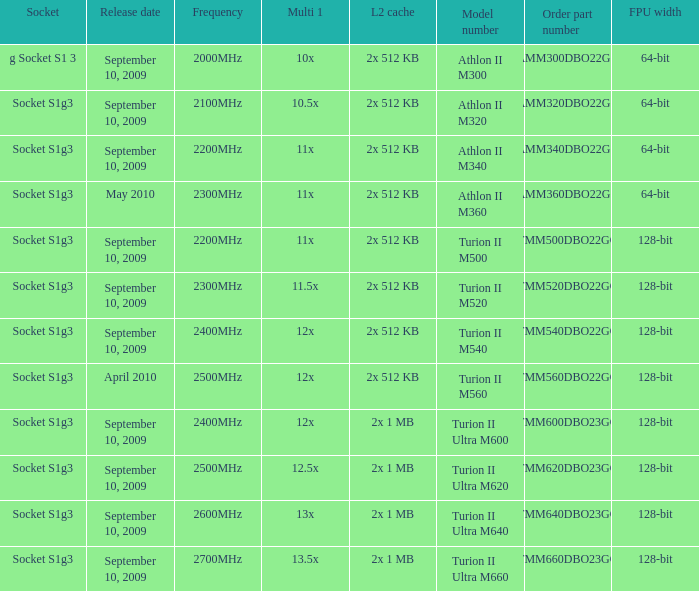Could you parse the entire table? {'header': ['Socket', 'Release date', 'Frequency', 'Multi 1', 'L2 cache', 'Model number', 'Order part number', 'FPU width'], 'rows': [['g Socket S1 3', 'September 10, 2009', '2000MHz', '10x', '2x 512 KB', 'Athlon II M300', 'AMM300DBO22GQ', '64-bit'], ['Socket S1g3', 'September 10, 2009', '2100MHz', '10.5x', '2x 512 KB', 'Athlon II M320', 'AMM320DBO22GQ', '64-bit'], ['Socket S1g3', 'September 10, 2009', '2200MHz', '11x', '2x 512 KB', 'Athlon II M340', 'AMM340DBO22GQ', '64-bit'], ['Socket S1g3', 'May 2010', '2300MHz', '11x', '2x 512 KB', 'Athlon II M360', 'AMM360DBO22GQ', '64-bit'], ['Socket S1g3', 'September 10, 2009', '2200MHz', '11x', '2x 512 KB', 'Turion II M500', 'TMM500DBO22GQ', '128-bit'], ['Socket S1g3', 'September 10, 2009', '2300MHz', '11.5x', '2x 512 KB', 'Turion II M520', 'TMM520DBO22GQ', '128-bit'], ['Socket S1g3', 'September 10, 2009', '2400MHz', '12x', '2x 512 KB', 'Turion II M540', 'TMM540DBO22GQ', '128-bit'], ['Socket S1g3', 'April 2010', '2500MHz', '12x', '2x 512 KB', 'Turion II M560', 'TMM560DBO22GQ', '128-bit'], ['Socket S1g3', 'September 10, 2009', '2400MHz', '12x', '2x 1 MB', 'Turion II Ultra M600', 'TMM600DBO23GQ', '128-bit'], ['Socket S1g3', 'September 10, 2009', '2500MHz', '12.5x', '2x 1 MB', 'Turion II Ultra M620', 'TMM620DBO23GQ', '128-bit'], ['Socket S1g3', 'September 10, 2009', '2600MHz', '13x', '2x 1 MB', 'Turion II Ultra M640', 'TMM640DBO23GQ', '128-bit'], ['Socket S1g3', 'September 10, 2009', '2700MHz', '13.5x', '2x 1 MB', 'Turion II Ultra M660', 'TMM660DBO23GQ', '128-bit']]} What is the release date of the 2x 512 kb L2 cache with a 11x multi 1, and a FPU width of 128-bit? September 10, 2009. 